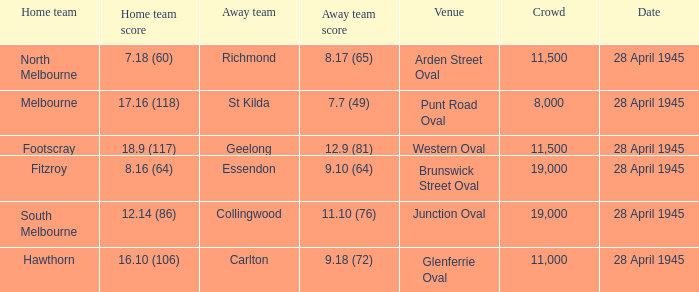What home team features an away team originating from richmond? North Melbourne. 